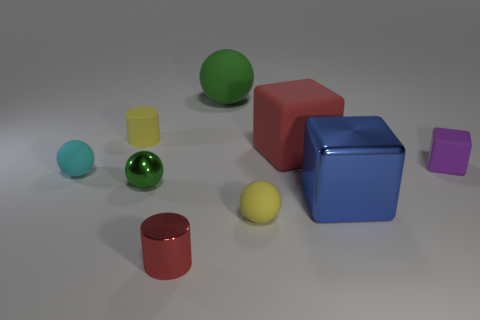There is a big thing that is the same color as the tiny metallic ball; what is its material?
Ensure brevity in your answer.  Rubber. Are there any other things that have the same shape as the big shiny object?
Offer a terse response. Yes. Is the material of the large blue cube the same as the yellow thing that is right of the small green metallic sphere?
Your response must be concise. No. What is the color of the large thing that is in front of the cube that is behind the small matte object to the right of the tiny yellow sphere?
Your answer should be compact. Blue. Are there any other things that have the same size as the red rubber object?
Offer a terse response. Yes. There is a tiny cube; does it have the same color as the tiny ball that is behind the metal sphere?
Give a very brief answer. No. The large metal block is what color?
Make the answer very short. Blue. The metallic object right of the metal thing that is in front of the tiny matte ball to the right of the tiny cyan rubber ball is what shape?
Your response must be concise. Cube. What number of other objects are the same color as the small rubber cube?
Make the answer very short. 0. Is the number of green matte balls behind the small yellow sphere greater than the number of small yellow things that are in front of the red cube?
Keep it short and to the point. No. 